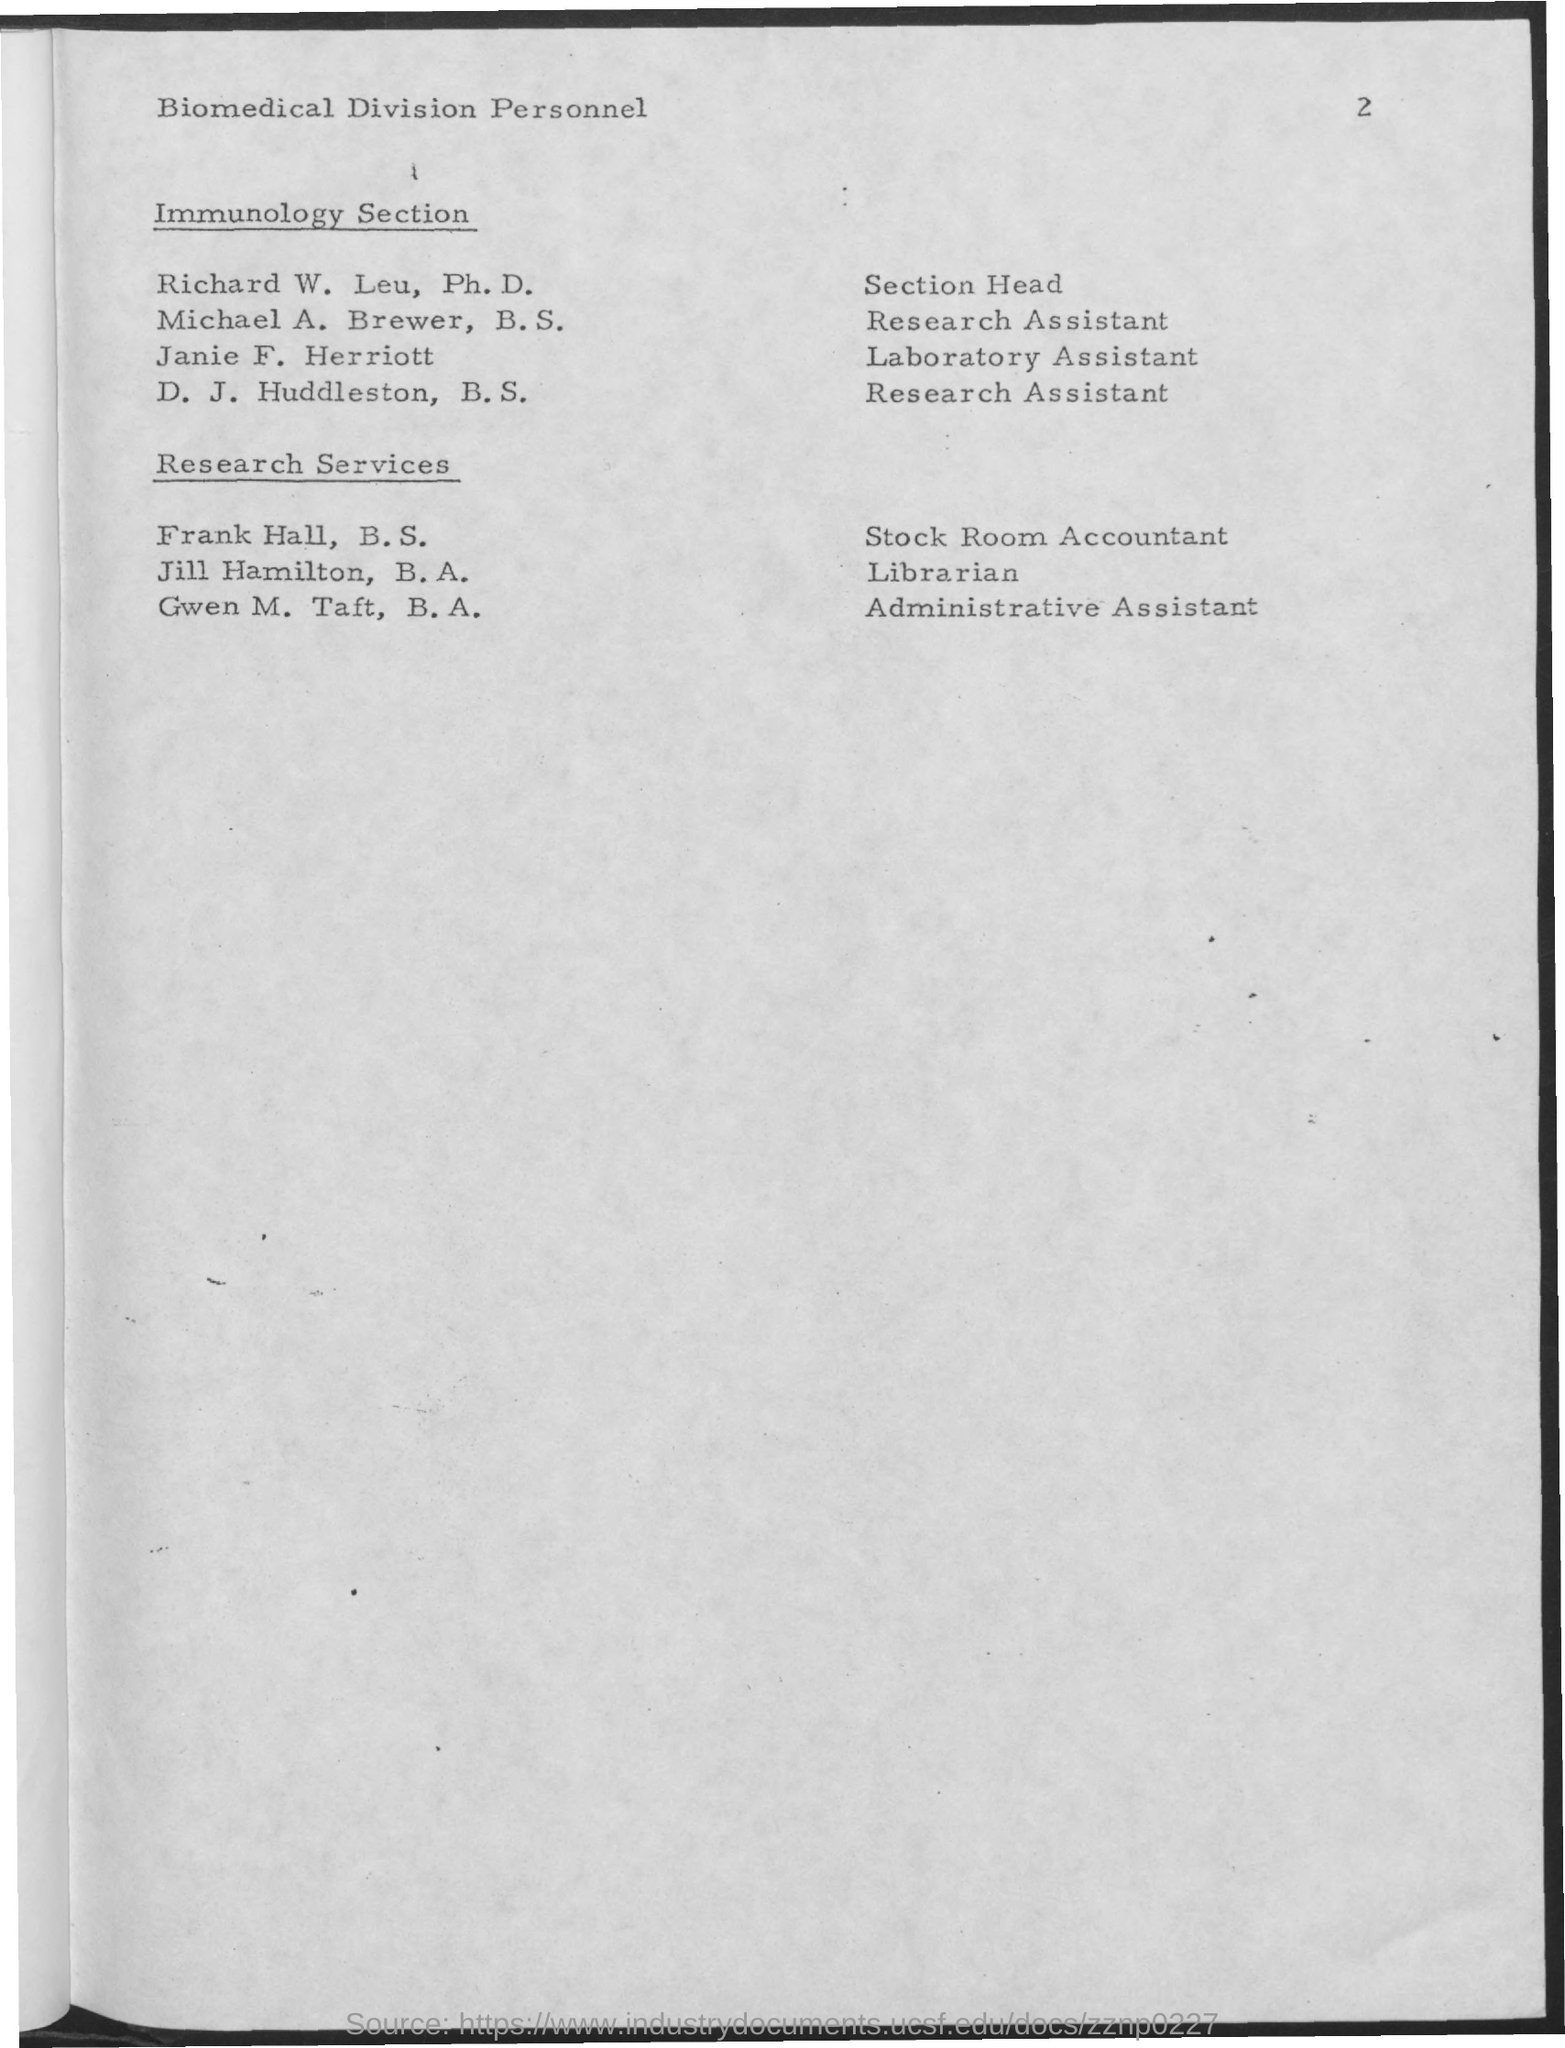Who is the laboratory assistant in the immunology section?
Give a very brief answer. Janie F. Herriott. What is the designation of Frank Hall, B.S.?
Your response must be concise. Stock Room Accountant. 